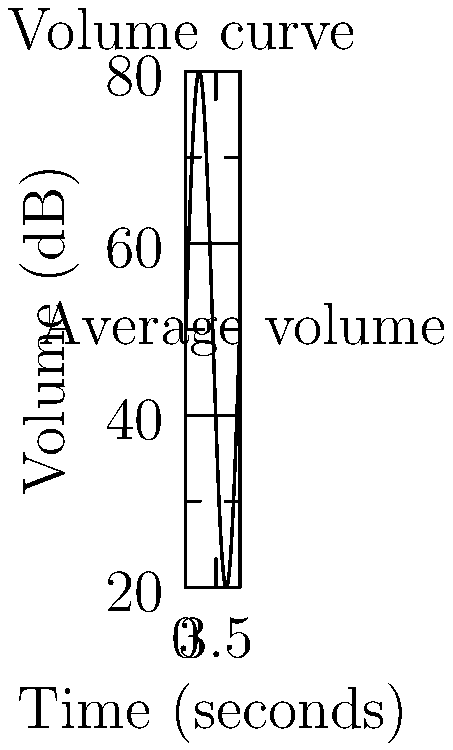In a 10-second video clip, the audio volume (in decibels) varies according to the function $V(t) = 50 + 30\sin(t)$, where $t$ is the time in seconds. Calculate the total area between the volume curve and the average volume line over the duration of the clip. How does this area relate to the perceived audio dynamics in the video? To solve this problem, we'll follow these steps:

1) The average volume is the constant term in the function, which is 50 dB.

2) The area we need to calculate is the integral of the absolute difference between the volume function and the average volume:

   $A = \int_0^{10} |V(t) - 50| dt = \int_0^{10} |30\sin(t)| dt$

3) Due to the absolute value, we need to split this integral at the points where $\sin(t) = 0$, which occurs at $t = 0, \pi, 2\pi, 3\pi$.

4) The integral becomes:

   $A = \int_0^{\pi} 30\sin(t) dt - \int_{\pi}^{2\pi} 30\sin(t) dt + \int_{2\pi}^{3\pi} 30\sin(t) dt + \int_{3\pi}^{10} 30\sin(t) dt$

5) Evaluating each integral:

   $A = [-30\cos(t)]_0^{\pi} - [-30\cos(t)]_{\pi}^{2\pi} + [-30\cos(t)]_{2\pi}^{3\pi} + [-30\cos(t)]_{3\pi}^{10}$
   
   $A = (-30(-1) - (-30)) - (-30(1) - (-30(-1))) + (-30(-1) - (-30(1))) + (-30\cos(10) - (-30(-1)))$
   
   $A = 60 + 60 + 60 + 30(\cos(10) + 1)$

6) Simplifying:

   $A = 180 + 30(\cos(10) + 1) \approx 210.46$ square dB-seconds

This area represents the total deviation from the average volume over time. A larger area indicates more dynamic audio, with more pronounced peaks and valleys in volume. This translates to a more varied and potentially engaging audio experience for viewers, adding emphasis to certain moments in the video.
Answer: $210.46$ square dB-seconds; larger area indicates more dynamic audio. 